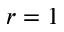<formula> <loc_0><loc_0><loc_500><loc_500>r = 1</formula> 